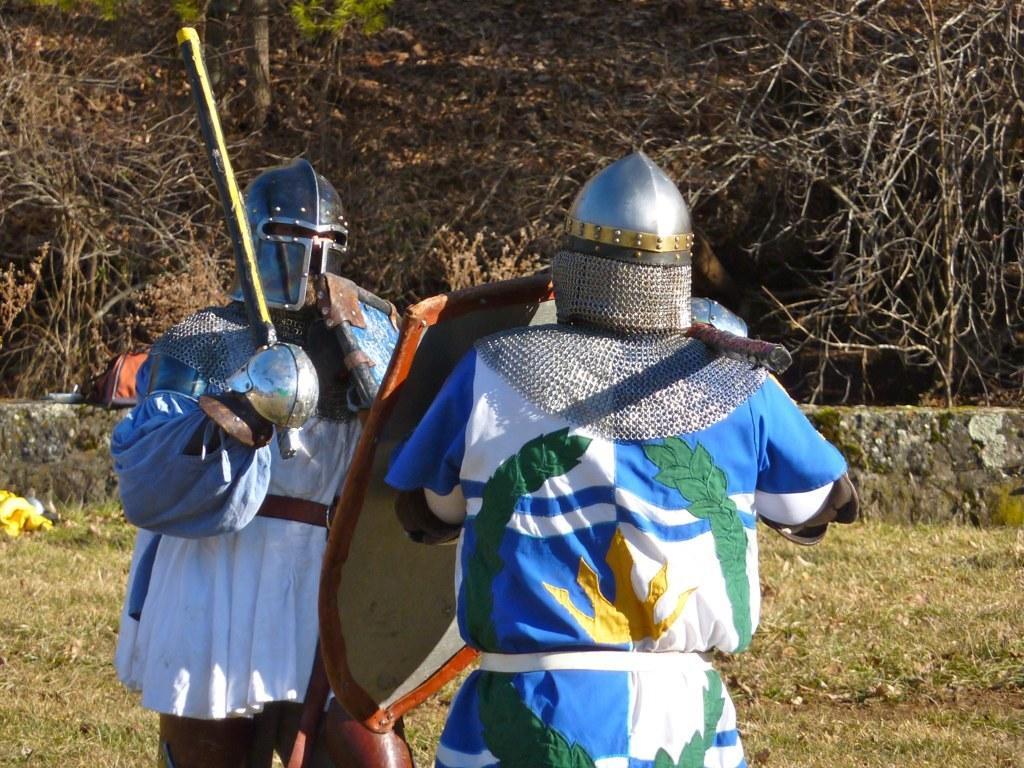In one or two sentences, can you explain what this image depicts? In the image we can see two people standing, wearing clothes, helmets and holding objects in their hands. Here we can see the grass, wall and trees. 